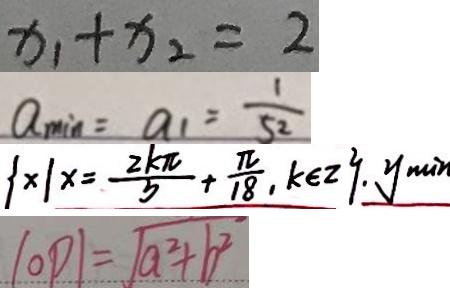Convert formula to latex. <formula><loc_0><loc_0><loc_500><loc_500>x _ { 1 } + x _ { 2 } = 2 
 a _ { \min } = a _ { 1 } = \frac { 1 } { 5 2 } 
 \{ x \vert x = \frac { 2 k \pi } { 5 } + \frac { \pi } { 1 8 } , k \in z \} . y _ { m i n } 
 \vert O P \vert = \sqrt { a ^ { 2 } + b ^ { 2 } }</formula> 